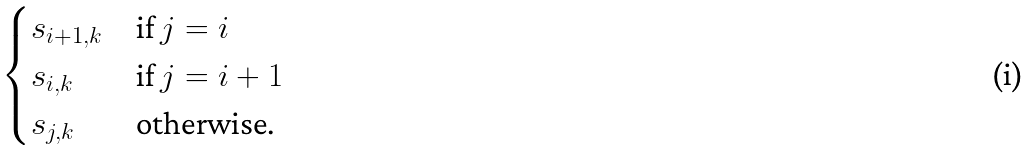Convert formula to latex. <formula><loc_0><loc_0><loc_500><loc_500>\begin{cases} s _ { i + 1 , k } & \text {if $j=i$} \\ s _ { i , k } & \text {if $j=i+1$} \\ s _ { j , k } & \text {otherwise.} \end{cases}</formula> 